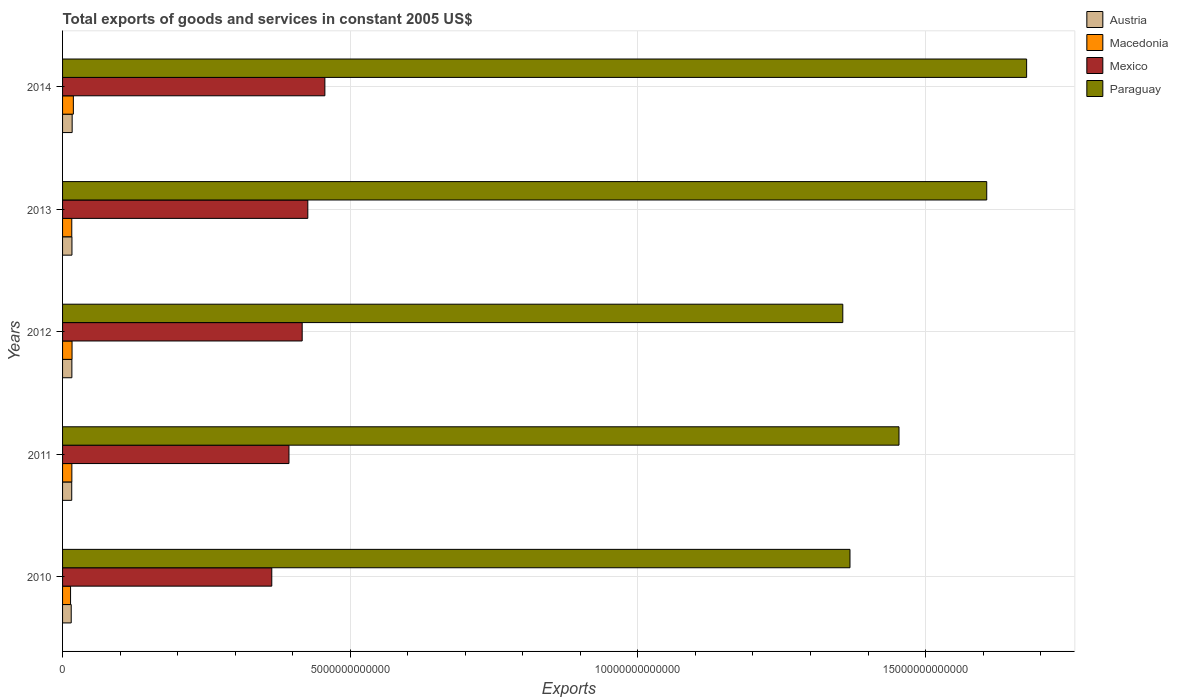How many different coloured bars are there?
Provide a short and direct response. 4. How many bars are there on the 3rd tick from the top?
Provide a short and direct response. 4. What is the total exports of goods and services in Mexico in 2013?
Keep it short and to the point. 4.26e+12. Across all years, what is the maximum total exports of goods and services in Paraguay?
Ensure brevity in your answer.  1.68e+13. Across all years, what is the minimum total exports of goods and services in Austria?
Give a very brief answer. 1.50e+11. In which year was the total exports of goods and services in Macedonia maximum?
Offer a very short reply. 2014. In which year was the total exports of goods and services in Macedonia minimum?
Ensure brevity in your answer.  2010. What is the total total exports of goods and services in Austria in the graph?
Your answer should be very brief. 8.01e+11. What is the difference between the total exports of goods and services in Austria in 2011 and that in 2014?
Ensure brevity in your answer.  -7.40e+09. What is the difference between the total exports of goods and services in Macedonia in 2014 and the total exports of goods and services in Paraguay in 2012?
Offer a terse response. -1.34e+13. What is the average total exports of goods and services in Austria per year?
Ensure brevity in your answer.  1.60e+11. In the year 2011, what is the difference between the total exports of goods and services in Austria and total exports of goods and services in Mexico?
Your answer should be compact. -3.78e+12. What is the ratio of the total exports of goods and services in Paraguay in 2012 to that in 2013?
Your answer should be compact. 0.84. Is the total exports of goods and services in Mexico in 2011 less than that in 2012?
Give a very brief answer. Yes. What is the difference between the highest and the second highest total exports of goods and services in Paraguay?
Offer a very short reply. 6.93e+11. What is the difference between the highest and the lowest total exports of goods and services in Macedonia?
Offer a very short reply. 4.85e+1. Is it the case that in every year, the sum of the total exports of goods and services in Macedonia and total exports of goods and services in Austria is greater than the sum of total exports of goods and services in Paraguay and total exports of goods and services in Mexico?
Your response must be concise. No. What does the 3rd bar from the top in 2013 represents?
Ensure brevity in your answer.  Macedonia. Is it the case that in every year, the sum of the total exports of goods and services in Austria and total exports of goods and services in Paraguay is greater than the total exports of goods and services in Mexico?
Offer a very short reply. Yes. How many bars are there?
Your answer should be compact. 20. What is the difference between two consecutive major ticks on the X-axis?
Make the answer very short. 5.00e+12. What is the title of the graph?
Ensure brevity in your answer.  Total exports of goods and services in constant 2005 US$. What is the label or title of the X-axis?
Keep it short and to the point. Exports. What is the label or title of the Y-axis?
Give a very brief answer. Years. What is the Exports of Austria in 2010?
Offer a terse response. 1.50e+11. What is the Exports of Macedonia in 2010?
Ensure brevity in your answer.  1.39e+11. What is the Exports of Mexico in 2010?
Ensure brevity in your answer.  3.64e+12. What is the Exports in Paraguay in 2010?
Give a very brief answer. 1.37e+13. What is the Exports of Austria in 2011?
Your answer should be compact. 1.59e+11. What is the Exports of Macedonia in 2011?
Provide a short and direct response. 1.62e+11. What is the Exports of Mexico in 2011?
Make the answer very short. 3.94e+12. What is the Exports of Paraguay in 2011?
Your response must be concise. 1.45e+13. What is the Exports in Austria in 2012?
Your answer should be very brief. 1.62e+11. What is the Exports in Macedonia in 2012?
Offer a terse response. 1.65e+11. What is the Exports of Mexico in 2012?
Make the answer very short. 4.16e+12. What is the Exports in Paraguay in 2012?
Your response must be concise. 1.36e+13. What is the Exports in Austria in 2013?
Ensure brevity in your answer.  1.63e+11. What is the Exports of Macedonia in 2013?
Your answer should be very brief. 1.60e+11. What is the Exports in Mexico in 2013?
Provide a short and direct response. 4.26e+12. What is the Exports in Paraguay in 2013?
Offer a terse response. 1.61e+13. What is the Exports of Austria in 2014?
Ensure brevity in your answer.  1.67e+11. What is the Exports of Macedonia in 2014?
Your answer should be very brief. 1.88e+11. What is the Exports of Mexico in 2014?
Offer a very short reply. 4.56e+12. What is the Exports of Paraguay in 2014?
Your answer should be compact. 1.68e+13. Across all years, what is the maximum Exports in Austria?
Offer a terse response. 1.67e+11. Across all years, what is the maximum Exports of Macedonia?
Your answer should be compact. 1.88e+11. Across all years, what is the maximum Exports of Mexico?
Offer a very short reply. 4.56e+12. Across all years, what is the maximum Exports in Paraguay?
Provide a succinct answer. 1.68e+13. Across all years, what is the minimum Exports of Austria?
Provide a short and direct response. 1.50e+11. Across all years, what is the minimum Exports in Macedonia?
Ensure brevity in your answer.  1.39e+11. Across all years, what is the minimum Exports in Mexico?
Your answer should be compact. 3.64e+12. Across all years, what is the minimum Exports of Paraguay?
Your answer should be compact. 1.36e+13. What is the total Exports of Austria in the graph?
Ensure brevity in your answer.  8.01e+11. What is the total Exports in Macedonia in the graph?
Provide a succinct answer. 8.13e+11. What is the total Exports of Mexico in the graph?
Ensure brevity in your answer.  2.06e+13. What is the total Exports in Paraguay in the graph?
Offer a very short reply. 7.46e+13. What is the difference between the Exports in Austria in 2010 and that in 2011?
Offer a terse response. -8.98e+09. What is the difference between the Exports in Macedonia in 2010 and that in 2011?
Your response must be concise. -2.24e+1. What is the difference between the Exports in Mexico in 2010 and that in 2011?
Provide a short and direct response. -2.99e+11. What is the difference between the Exports of Paraguay in 2010 and that in 2011?
Offer a terse response. -8.52e+11. What is the difference between the Exports of Austria in 2010 and that in 2012?
Your answer should be compact. -1.16e+1. What is the difference between the Exports of Macedonia in 2010 and that in 2012?
Provide a short and direct response. -2.56e+1. What is the difference between the Exports in Mexico in 2010 and that in 2012?
Keep it short and to the point. -5.29e+11. What is the difference between the Exports of Paraguay in 2010 and that in 2012?
Your answer should be compact. 1.25e+11. What is the difference between the Exports of Austria in 2010 and that in 2013?
Provide a short and direct response. -1.29e+1. What is the difference between the Exports of Macedonia in 2010 and that in 2013?
Give a very brief answer. -2.12e+1. What is the difference between the Exports of Mexico in 2010 and that in 2013?
Your response must be concise. -6.26e+11. What is the difference between the Exports in Paraguay in 2010 and that in 2013?
Make the answer very short. -2.38e+12. What is the difference between the Exports of Austria in 2010 and that in 2014?
Give a very brief answer. -1.64e+1. What is the difference between the Exports of Macedonia in 2010 and that in 2014?
Provide a succinct answer. -4.85e+1. What is the difference between the Exports of Mexico in 2010 and that in 2014?
Your answer should be compact. -9.23e+11. What is the difference between the Exports of Paraguay in 2010 and that in 2014?
Your response must be concise. -3.07e+12. What is the difference between the Exports in Austria in 2011 and that in 2012?
Give a very brief answer. -2.64e+09. What is the difference between the Exports in Macedonia in 2011 and that in 2012?
Your answer should be very brief. -3.15e+09. What is the difference between the Exports of Mexico in 2011 and that in 2012?
Your answer should be very brief. -2.30e+11. What is the difference between the Exports of Paraguay in 2011 and that in 2012?
Your answer should be very brief. 9.77e+11. What is the difference between the Exports of Austria in 2011 and that in 2013?
Your answer should be compact. -3.95e+09. What is the difference between the Exports of Macedonia in 2011 and that in 2013?
Ensure brevity in your answer.  1.27e+09. What is the difference between the Exports of Mexico in 2011 and that in 2013?
Your response must be concise. -3.28e+11. What is the difference between the Exports in Paraguay in 2011 and that in 2013?
Offer a very short reply. -1.52e+12. What is the difference between the Exports in Austria in 2011 and that in 2014?
Your answer should be compact. -7.40e+09. What is the difference between the Exports of Macedonia in 2011 and that in 2014?
Offer a terse response. -2.60e+1. What is the difference between the Exports of Mexico in 2011 and that in 2014?
Make the answer very short. -6.24e+11. What is the difference between the Exports of Paraguay in 2011 and that in 2014?
Ensure brevity in your answer.  -2.22e+12. What is the difference between the Exports in Austria in 2012 and that in 2013?
Give a very brief answer. -1.32e+09. What is the difference between the Exports of Macedonia in 2012 and that in 2013?
Provide a short and direct response. 4.42e+09. What is the difference between the Exports in Mexico in 2012 and that in 2013?
Give a very brief answer. -9.78e+1. What is the difference between the Exports in Paraguay in 2012 and that in 2013?
Your answer should be compact. -2.50e+12. What is the difference between the Exports in Austria in 2012 and that in 2014?
Your answer should be very brief. -4.76e+09. What is the difference between the Exports of Macedonia in 2012 and that in 2014?
Your answer should be very brief. -2.29e+1. What is the difference between the Exports in Mexico in 2012 and that in 2014?
Offer a very short reply. -3.94e+11. What is the difference between the Exports in Paraguay in 2012 and that in 2014?
Offer a terse response. -3.20e+12. What is the difference between the Exports of Austria in 2013 and that in 2014?
Offer a very short reply. -3.45e+09. What is the difference between the Exports in Macedonia in 2013 and that in 2014?
Keep it short and to the point. -2.73e+1. What is the difference between the Exports of Mexico in 2013 and that in 2014?
Offer a very short reply. -2.97e+11. What is the difference between the Exports in Paraguay in 2013 and that in 2014?
Provide a succinct answer. -6.93e+11. What is the difference between the Exports of Austria in 2010 and the Exports of Macedonia in 2011?
Provide a short and direct response. -1.13e+1. What is the difference between the Exports in Austria in 2010 and the Exports in Mexico in 2011?
Your answer should be very brief. -3.78e+12. What is the difference between the Exports of Austria in 2010 and the Exports of Paraguay in 2011?
Offer a terse response. -1.44e+13. What is the difference between the Exports of Macedonia in 2010 and the Exports of Mexico in 2011?
Your response must be concise. -3.80e+12. What is the difference between the Exports in Macedonia in 2010 and the Exports in Paraguay in 2011?
Keep it short and to the point. -1.44e+13. What is the difference between the Exports in Mexico in 2010 and the Exports in Paraguay in 2011?
Ensure brevity in your answer.  -1.09e+13. What is the difference between the Exports in Austria in 2010 and the Exports in Macedonia in 2012?
Keep it short and to the point. -1.44e+1. What is the difference between the Exports in Austria in 2010 and the Exports in Mexico in 2012?
Provide a short and direct response. -4.01e+12. What is the difference between the Exports in Austria in 2010 and the Exports in Paraguay in 2012?
Offer a very short reply. -1.34e+13. What is the difference between the Exports in Macedonia in 2010 and the Exports in Mexico in 2012?
Give a very brief answer. -4.03e+12. What is the difference between the Exports in Macedonia in 2010 and the Exports in Paraguay in 2012?
Your answer should be compact. -1.34e+13. What is the difference between the Exports in Mexico in 2010 and the Exports in Paraguay in 2012?
Give a very brief answer. -9.93e+12. What is the difference between the Exports of Austria in 2010 and the Exports of Macedonia in 2013?
Provide a short and direct response. -1.00e+1. What is the difference between the Exports of Austria in 2010 and the Exports of Mexico in 2013?
Ensure brevity in your answer.  -4.11e+12. What is the difference between the Exports in Austria in 2010 and the Exports in Paraguay in 2013?
Offer a very short reply. -1.59e+13. What is the difference between the Exports in Macedonia in 2010 and the Exports in Mexico in 2013?
Keep it short and to the point. -4.12e+12. What is the difference between the Exports in Macedonia in 2010 and the Exports in Paraguay in 2013?
Ensure brevity in your answer.  -1.59e+13. What is the difference between the Exports of Mexico in 2010 and the Exports of Paraguay in 2013?
Keep it short and to the point. -1.24e+13. What is the difference between the Exports of Austria in 2010 and the Exports of Macedonia in 2014?
Make the answer very short. -3.73e+1. What is the difference between the Exports of Austria in 2010 and the Exports of Mexico in 2014?
Your answer should be very brief. -4.41e+12. What is the difference between the Exports of Austria in 2010 and the Exports of Paraguay in 2014?
Offer a terse response. -1.66e+13. What is the difference between the Exports of Macedonia in 2010 and the Exports of Mexico in 2014?
Give a very brief answer. -4.42e+12. What is the difference between the Exports in Macedonia in 2010 and the Exports in Paraguay in 2014?
Offer a very short reply. -1.66e+13. What is the difference between the Exports of Mexico in 2010 and the Exports of Paraguay in 2014?
Make the answer very short. -1.31e+13. What is the difference between the Exports in Austria in 2011 and the Exports in Macedonia in 2012?
Offer a terse response. -5.44e+09. What is the difference between the Exports of Austria in 2011 and the Exports of Mexico in 2012?
Your answer should be compact. -4.01e+12. What is the difference between the Exports in Austria in 2011 and the Exports in Paraguay in 2012?
Ensure brevity in your answer.  -1.34e+13. What is the difference between the Exports of Macedonia in 2011 and the Exports of Mexico in 2012?
Offer a very short reply. -4.00e+12. What is the difference between the Exports of Macedonia in 2011 and the Exports of Paraguay in 2012?
Your response must be concise. -1.34e+13. What is the difference between the Exports in Mexico in 2011 and the Exports in Paraguay in 2012?
Give a very brief answer. -9.63e+12. What is the difference between the Exports in Austria in 2011 and the Exports in Macedonia in 2013?
Your answer should be compact. -1.02e+09. What is the difference between the Exports in Austria in 2011 and the Exports in Mexico in 2013?
Keep it short and to the point. -4.10e+12. What is the difference between the Exports of Austria in 2011 and the Exports of Paraguay in 2013?
Keep it short and to the point. -1.59e+13. What is the difference between the Exports of Macedonia in 2011 and the Exports of Mexico in 2013?
Ensure brevity in your answer.  -4.10e+12. What is the difference between the Exports of Macedonia in 2011 and the Exports of Paraguay in 2013?
Give a very brief answer. -1.59e+13. What is the difference between the Exports of Mexico in 2011 and the Exports of Paraguay in 2013?
Your answer should be very brief. -1.21e+13. What is the difference between the Exports in Austria in 2011 and the Exports in Macedonia in 2014?
Your response must be concise. -2.83e+1. What is the difference between the Exports in Austria in 2011 and the Exports in Mexico in 2014?
Your answer should be compact. -4.40e+12. What is the difference between the Exports of Austria in 2011 and the Exports of Paraguay in 2014?
Provide a succinct answer. -1.66e+13. What is the difference between the Exports of Macedonia in 2011 and the Exports of Mexico in 2014?
Ensure brevity in your answer.  -4.40e+12. What is the difference between the Exports in Macedonia in 2011 and the Exports in Paraguay in 2014?
Ensure brevity in your answer.  -1.66e+13. What is the difference between the Exports of Mexico in 2011 and the Exports of Paraguay in 2014?
Ensure brevity in your answer.  -1.28e+13. What is the difference between the Exports of Austria in 2012 and the Exports of Macedonia in 2013?
Provide a short and direct response. 1.62e+09. What is the difference between the Exports in Austria in 2012 and the Exports in Mexico in 2013?
Make the answer very short. -4.10e+12. What is the difference between the Exports of Austria in 2012 and the Exports of Paraguay in 2013?
Your response must be concise. -1.59e+13. What is the difference between the Exports of Macedonia in 2012 and the Exports of Mexico in 2013?
Give a very brief answer. -4.10e+12. What is the difference between the Exports in Macedonia in 2012 and the Exports in Paraguay in 2013?
Keep it short and to the point. -1.59e+13. What is the difference between the Exports in Mexico in 2012 and the Exports in Paraguay in 2013?
Offer a very short reply. -1.19e+13. What is the difference between the Exports of Austria in 2012 and the Exports of Macedonia in 2014?
Ensure brevity in your answer.  -2.57e+1. What is the difference between the Exports of Austria in 2012 and the Exports of Mexico in 2014?
Your response must be concise. -4.40e+12. What is the difference between the Exports in Austria in 2012 and the Exports in Paraguay in 2014?
Keep it short and to the point. -1.66e+13. What is the difference between the Exports of Macedonia in 2012 and the Exports of Mexico in 2014?
Your answer should be very brief. -4.39e+12. What is the difference between the Exports of Macedonia in 2012 and the Exports of Paraguay in 2014?
Provide a short and direct response. -1.66e+13. What is the difference between the Exports in Mexico in 2012 and the Exports in Paraguay in 2014?
Ensure brevity in your answer.  -1.26e+13. What is the difference between the Exports of Austria in 2013 and the Exports of Macedonia in 2014?
Provide a short and direct response. -2.44e+1. What is the difference between the Exports of Austria in 2013 and the Exports of Mexico in 2014?
Provide a short and direct response. -4.40e+12. What is the difference between the Exports in Austria in 2013 and the Exports in Paraguay in 2014?
Give a very brief answer. -1.66e+13. What is the difference between the Exports of Macedonia in 2013 and the Exports of Mexico in 2014?
Offer a very short reply. -4.40e+12. What is the difference between the Exports of Macedonia in 2013 and the Exports of Paraguay in 2014?
Keep it short and to the point. -1.66e+13. What is the difference between the Exports of Mexico in 2013 and the Exports of Paraguay in 2014?
Keep it short and to the point. -1.25e+13. What is the average Exports in Austria per year?
Give a very brief answer. 1.60e+11. What is the average Exports in Macedonia per year?
Provide a succinct answer. 1.63e+11. What is the average Exports in Mexico per year?
Provide a succinct answer. 4.11e+12. What is the average Exports of Paraguay per year?
Provide a short and direct response. 1.49e+13. In the year 2010, what is the difference between the Exports in Austria and Exports in Macedonia?
Make the answer very short. 1.12e+1. In the year 2010, what is the difference between the Exports in Austria and Exports in Mexico?
Your response must be concise. -3.49e+12. In the year 2010, what is the difference between the Exports of Austria and Exports of Paraguay?
Provide a short and direct response. -1.35e+13. In the year 2010, what is the difference between the Exports in Macedonia and Exports in Mexico?
Your answer should be compact. -3.50e+12. In the year 2010, what is the difference between the Exports of Macedonia and Exports of Paraguay?
Your response must be concise. -1.35e+13. In the year 2010, what is the difference between the Exports of Mexico and Exports of Paraguay?
Provide a succinct answer. -1.01e+13. In the year 2011, what is the difference between the Exports of Austria and Exports of Macedonia?
Offer a terse response. -2.29e+09. In the year 2011, what is the difference between the Exports of Austria and Exports of Mexico?
Make the answer very short. -3.78e+12. In the year 2011, what is the difference between the Exports of Austria and Exports of Paraguay?
Provide a short and direct response. -1.44e+13. In the year 2011, what is the difference between the Exports in Macedonia and Exports in Mexico?
Provide a succinct answer. -3.77e+12. In the year 2011, what is the difference between the Exports of Macedonia and Exports of Paraguay?
Ensure brevity in your answer.  -1.44e+13. In the year 2011, what is the difference between the Exports in Mexico and Exports in Paraguay?
Give a very brief answer. -1.06e+13. In the year 2012, what is the difference between the Exports of Austria and Exports of Macedonia?
Provide a succinct answer. -2.80e+09. In the year 2012, what is the difference between the Exports of Austria and Exports of Mexico?
Provide a short and direct response. -4.00e+12. In the year 2012, what is the difference between the Exports of Austria and Exports of Paraguay?
Offer a terse response. -1.34e+13. In the year 2012, what is the difference between the Exports in Macedonia and Exports in Mexico?
Offer a very short reply. -4.00e+12. In the year 2012, what is the difference between the Exports of Macedonia and Exports of Paraguay?
Provide a short and direct response. -1.34e+13. In the year 2012, what is the difference between the Exports in Mexico and Exports in Paraguay?
Your response must be concise. -9.40e+12. In the year 2013, what is the difference between the Exports in Austria and Exports in Macedonia?
Your response must be concise. 2.93e+09. In the year 2013, what is the difference between the Exports of Austria and Exports of Mexico?
Offer a terse response. -4.10e+12. In the year 2013, what is the difference between the Exports of Austria and Exports of Paraguay?
Make the answer very short. -1.59e+13. In the year 2013, what is the difference between the Exports in Macedonia and Exports in Mexico?
Give a very brief answer. -4.10e+12. In the year 2013, what is the difference between the Exports in Macedonia and Exports in Paraguay?
Provide a short and direct response. -1.59e+13. In the year 2013, what is the difference between the Exports of Mexico and Exports of Paraguay?
Provide a short and direct response. -1.18e+13. In the year 2014, what is the difference between the Exports in Austria and Exports in Macedonia?
Provide a short and direct response. -2.09e+1. In the year 2014, what is the difference between the Exports of Austria and Exports of Mexico?
Provide a short and direct response. -4.39e+12. In the year 2014, what is the difference between the Exports of Austria and Exports of Paraguay?
Offer a terse response. -1.66e+13. In the year 2014, what is the difference between the Exports in Macedonia and Exports in Mexico?
Provide a short and direct response. -4.37e+12. In the year 2014, what is the difference between the Exports in Macedonia and Exports in Paraguay?
Offer a very short reply. -1.66e+13. In the year 2014, what is the difference between the Exports in Mexico and Exports in Paraguay?
Provide a succinct answer. -1.22e+13. What is the ratio of the Exports in Austria in 2010 to that in 2011?
Provide a succinct answer. 0.94. What is the ratio of the Exports in Macedonia in 2010 to that in 2011?
Keep it short and to the point. 0.86. What is the ratio of the Exports of Mexico in 2010 to that in 2011?
Provide a succinct answer. 0.92. What is the ratio of the Exports of Paraguay in 2010 to that in 2011?
Your answer should be compact. 0.94. What is the ratio of the Exports in Austria in 2010 to that in 2012?
Offer a very short reply. 0.93. What is the ratio of the Exports in Macedonia in 2010 to that in 2012?
Ensure brevity in your answer.  0.84. What is the ratio of the Exports in Mexico in 2010 to that in 2012?
Offer a very short reply. 0.87. What is the ratio of the Exports of Paraguay in 2010 to that in 2012?
Offer a terse response. 1.01. What is the ratio of the Exports of Austria in 2010 to that in 2013?
Provide a short and direct response. 0.92. What is the ratio of the Exports of Macedonia in 2010 to that in 2013?
Keep it short and to the point. 0.87. What is the ratio of the Exports in Mexico in 2010 to that in 2013?
Make the answer very short. 0.85. What is the ratio of the Exports in Paraguay in 2010 to that in 2013?
Offer a terse response. 0.85. What is the ratio of the Exports in Austria in 2010 to that in 2014?
Ensure brevity in your answer.  0.9. What is the ratio of the Exports in Macedonia in 2010 to that in 2014?
Offer a very short reply. 0.74. What is the ratio of the Exports of Mexico in 2010 to that in 2014?
Your answer should be compact. 0.8. What is the ratio of the Exports of Paraguay in 2010 to that in 2014?
Your answer should be compact. 0.82. What is the ratio of the Exports in Austria in 2011 to that in 2012?
Your response must be concise. 0.98. What is the ratio of the Exports of Macedonia in 2011 to that in 2012?
Make the answer very short. 0.98. What is the ratio of the Exports in Mexico in 2011 to that in 2012?
Offer a very short reply. 0.94. What is the ratio of the Exports of Paraguay in 2011 to that in 2012?
Your response must be concise. 1.07. What is the ratio of the Exports of Austria in 2011 to that in 2013?
Keep it short and to the point. 0.98. What is the ratio of the Exports in Macedonia in 2011 to that in 2013?
Your answer should be compact. 1.01. What is the ratio of the Exports of Mexico in 2011 to that in 2013?
Your response must be concise. 0.92. What is the ratio of the Exports of Paraguay in 2011 to that in 2013?
Keep it short and to the point. 0.91. What is the ratio of the Exports in Austria in 2011 to that in 2014?
Your response must be concise. 0.96. What is the ratio of the Exports in Macedonia in 2011 to that in 2014?
Your response must be concise. 0.86. What is the ratio of the Exports of Mexico in 2011 to that in 2014?
Make the answer very short. 0.86. What is the ratio of the Exports of Paraguay in 2011 to that in 2014?
Make the answer very short. 0.87. What is the ratio of the Exports of Macedonia in 2012 to that in 2013?
Keep it short and to the point. 1.03. What is the ratio of the Exports of Mexico in 2012 to that in 2013?
Ensure brevity in your answer.  0.98. What is the ratio of the Exports of Paraguay in 2012 to that in 2013?
Provide a succinct answer. 0.84. What is the ratio of the Exports of Austria in 2012 to that in 2014?
Give a very brief answer. 0.97. What is the ratio of the Exports in Macedonia in 2012 to that in 2014?
Give a very brief answer. 0.88. What is the ratio of the Exports in Mexico in 2012 to that in 2014?
Your response must be concise. 0.91. What is the ratio of the Exports of Paraguay in 2012 to that in 2014?
Offer a terse response. 0.81. What is the ratio of the Exports of Austria in 2013 to that in 2014?
Your response must be concise. 0.98. What is the ratio of the Exports in Macedonia in 2013 to that in 2014?
Your response must be concise. 0.85. What is the ratio of the Exports of Mexico in 2013 to that in 2014?
Offer a terse response. 0.93. What is the ratio of the Exports of Paraguay in 2013 to that in 2014?
Offer a terse response. 0.96. What is the difference between the highest and the second highest Exports in Austria?
Ensure brevity in your answer.  3.45e+09. What is the difference between the highest and the second highest Exports of Macedonia?
Keep it short and to the point. 2.29e+1. What is the difference between the highest and the second highest Exports in Mexico?
Give a very brief answer. 2.97e+11. What is the difference between the highest and the second highest Exports in Paraguay?
Your answer should be very brief. 6.93e+11. What is the difference between the highest and the lowest Exports of Austria?
Provide a succinct answer. 1.64e+1. What is the difference between the highest and the lowest Exports of Macedonia?
Provide a succinct answer. 4.85e+1. What is the difference between the highest and the lowest Exports in Mexico?
Give a very brief answer. 9.23e+11. What is the difference between the highest and the lowest Exports of Paraguay?
Give a very brief answer. 3.20e+12. 